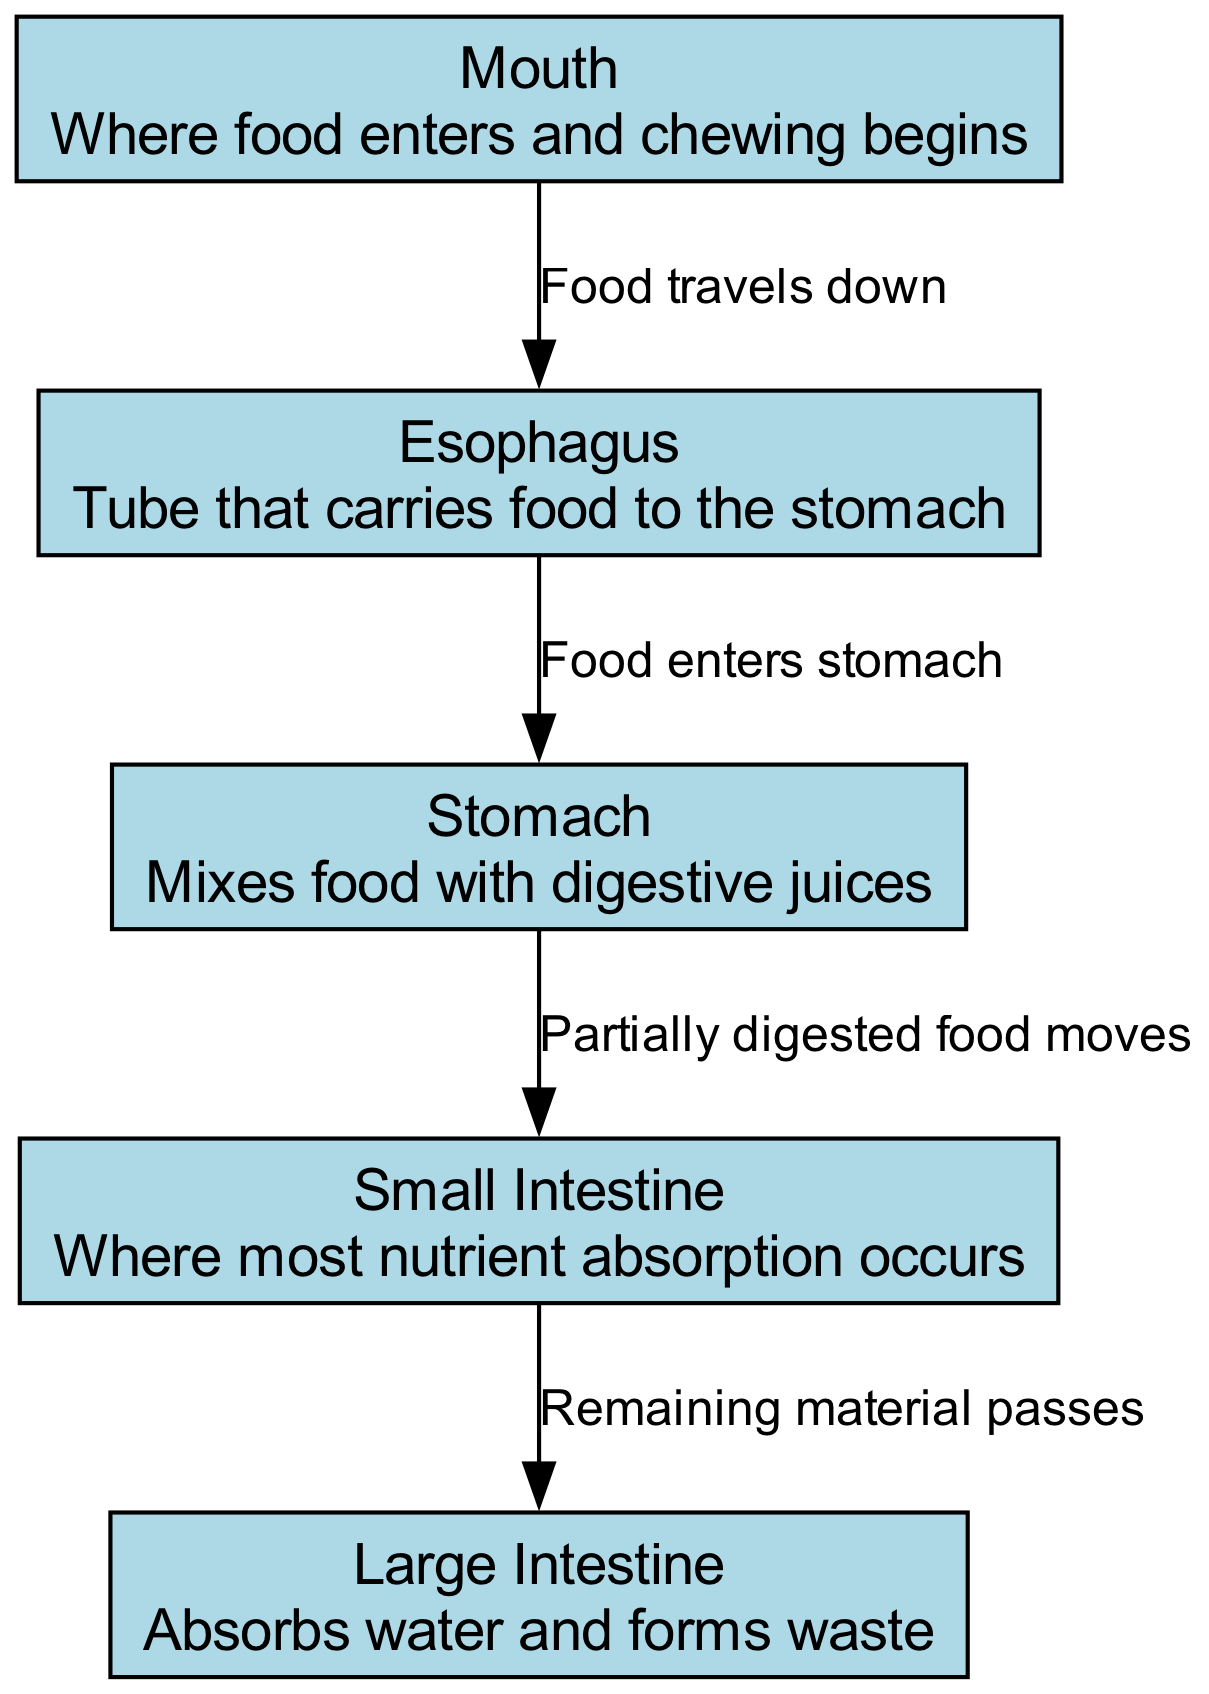What is the first part of the dog's digestive system where food enters? According to the diagram, food first enters at the "Mouth".
Answer: Mouth What does the esophagus do? The esophagus is defined as the tube that "carries food to the stomach", indicating its role in transporting food.
Answer: Carries food to the stomach How many nodes are represented in the diagram? The diagram features a total of 5 nodes: Mouth, Esophagus, Stomach, Small Intestine, and Large Intestine.
Answer: 5 What happens to partially digested food after it leaves the stomach? The diagram states that "Partially digested food moves" into the small intestine after leaving the stomach, indicating this sequential process.
Answer: Moves to small intestine What is the function of the large intestine? The large intestine is described as "absorbs water and forms waste" in the diagram, highlighting its primary function in the digestive system.
Answer: Absorbs water and forms waste What is the relationship between the stomach and the small intestine? The diagram indicates that the stomach connects to the small intestine, specifically stating that "Partially digested food moves" from the stomach to the small intestine. This shows a direct flow of food.
Answer: Partially digested food moves What is the last part of the dog's digestive system? The diagram clearly labels the "Large Intestine" as the final component in the sequence of the digestive system, marking its last stage.
Answer: Large Intestine How does food travel from the mouth to the stomach? The diagram describes this process with the label "Food travels down" indicating the direction from the mouth to the esophagus and then to the stomach.
Answer: Food travels down What does the small intestine primarily do? According to the diagram, the small intestine is where "most nutrient absorption occurs," emphasizing its critical role in digestion.
Answer: Most nutrient absorption occurs 